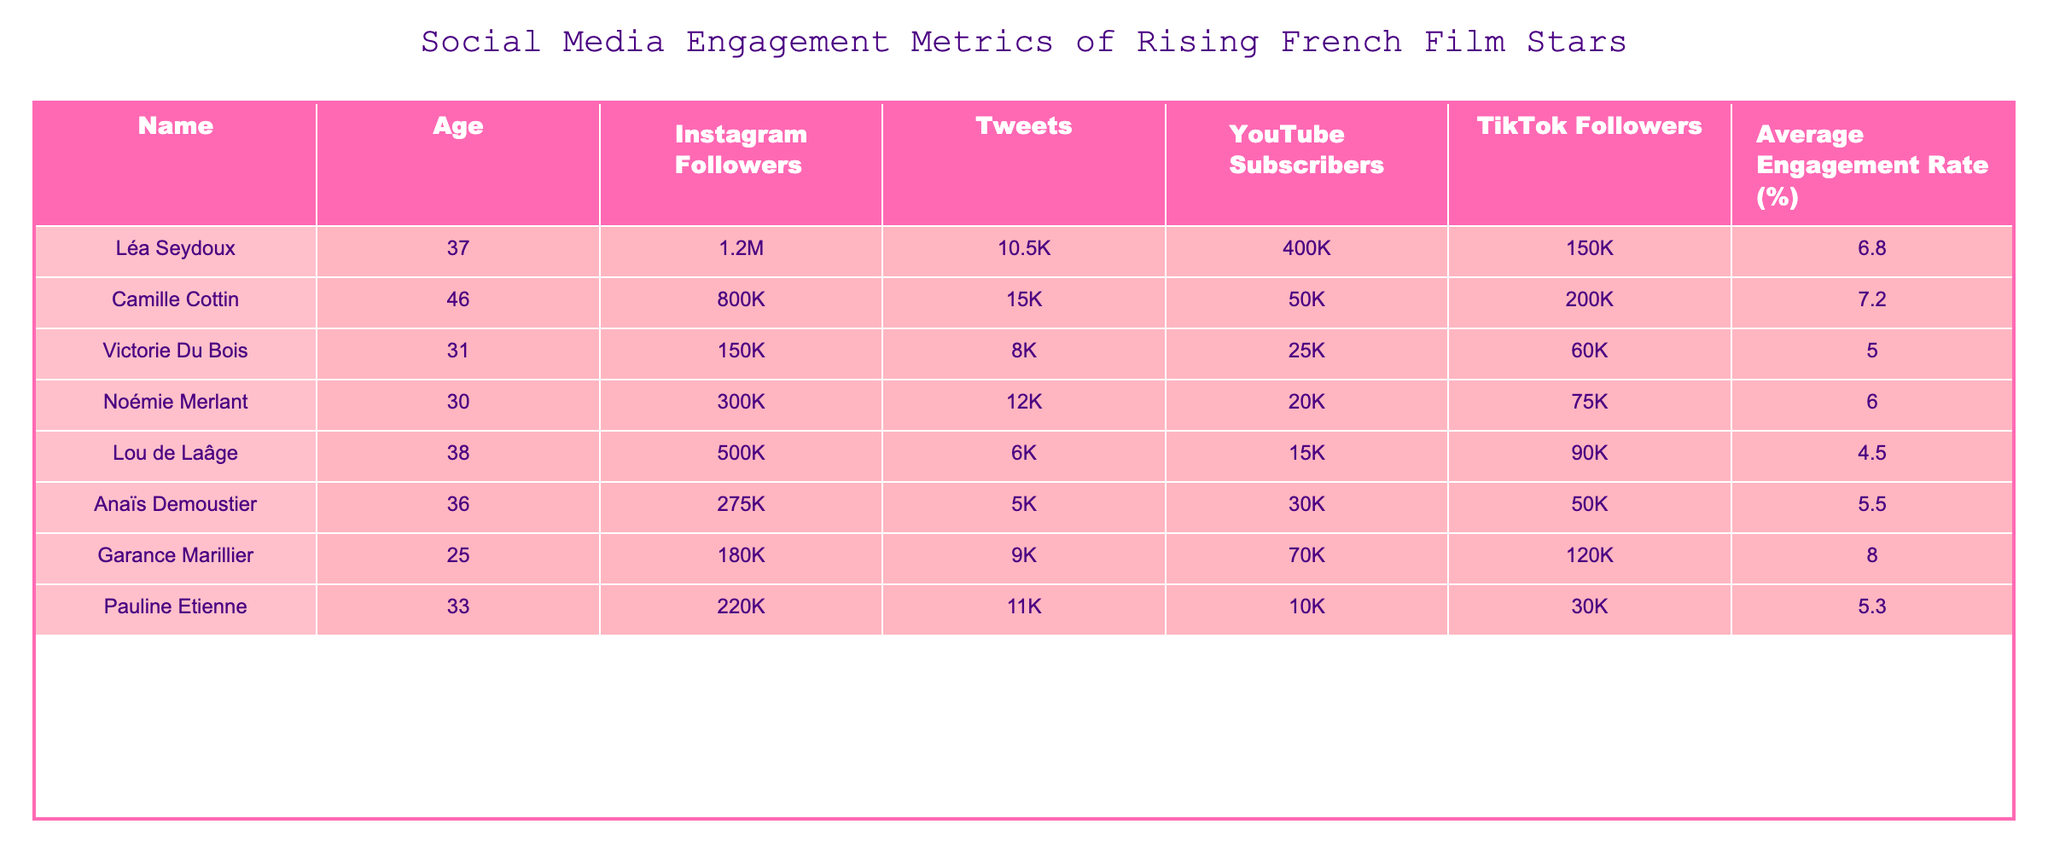What is the most followed star on Instagram? By looking at the Instagram Followers column, Léa Seydoux has the highest number of followers at 1.2 million.
Answer: 1.2M Which actress has the lowest TikTok followers? In the TikTok Followers column, Lou de Laâge has the lowest count with 90K followers.
Answer: 90K What is the average engagement rate of all the actresses listed? To find the average engagement rate, we sum the engagement rates (6.8 + 7.2 + 5.0 + 6.0 + 4.5 + 5.5 + 8.0 + 5.3) = 48.3, then divide by the number of actresses (8): 48.3 / 8 = 6.0375. Rounding to two decimal places, it is approximately 6.04.
Answer: 6.04 Do more followers on Instagram correlate with a higher engagement rate? By closely observing the data, Léa Seydoux with 1.2M followers has a 6.8% engagement rate, while Camille Cottin with 800K followers has a higher engagement rate of 7.2%. Thus, the correlation is not straightforward and shows variability.
Answer: No How many total YouTube subscribers do all the actresses have combined? We can find the total by adding each actress's YouTube Subscribers: 400K + 50K + 25K + 20K + 15K + 30K + 70K + 10K = 620K.
Answer: 620K Which actress is younger, Garance Marillier or Noémie Merlant? Garance Marillier is 25 years old while Noémie Merlant is 30 years old. Since 25 is less than 30, Garance Marillier is younger.
Answer: Garance Marillier Is there any actress who has a higher average engagement rate than Garance Marillier? Comparing the average engagement rates, Garance Marillier has 8.0%. Checking other actresses, Camille Cottin has a rate of 7.2% and Léa Seydoux has 6.8%. Therefore, there are no actresses with a higher rate than Garance Marillier.
Answer: No What is the difference in the average engagement rate between the youngest and oldest actresses? The youngest actress, Garance Marillier, has an engagement rate of 8.0%, and the oldest, Camille Cottin, has 7.2%. The difference is 8.0 - 7.2 = 0.8%.
Answer: 0.8% 